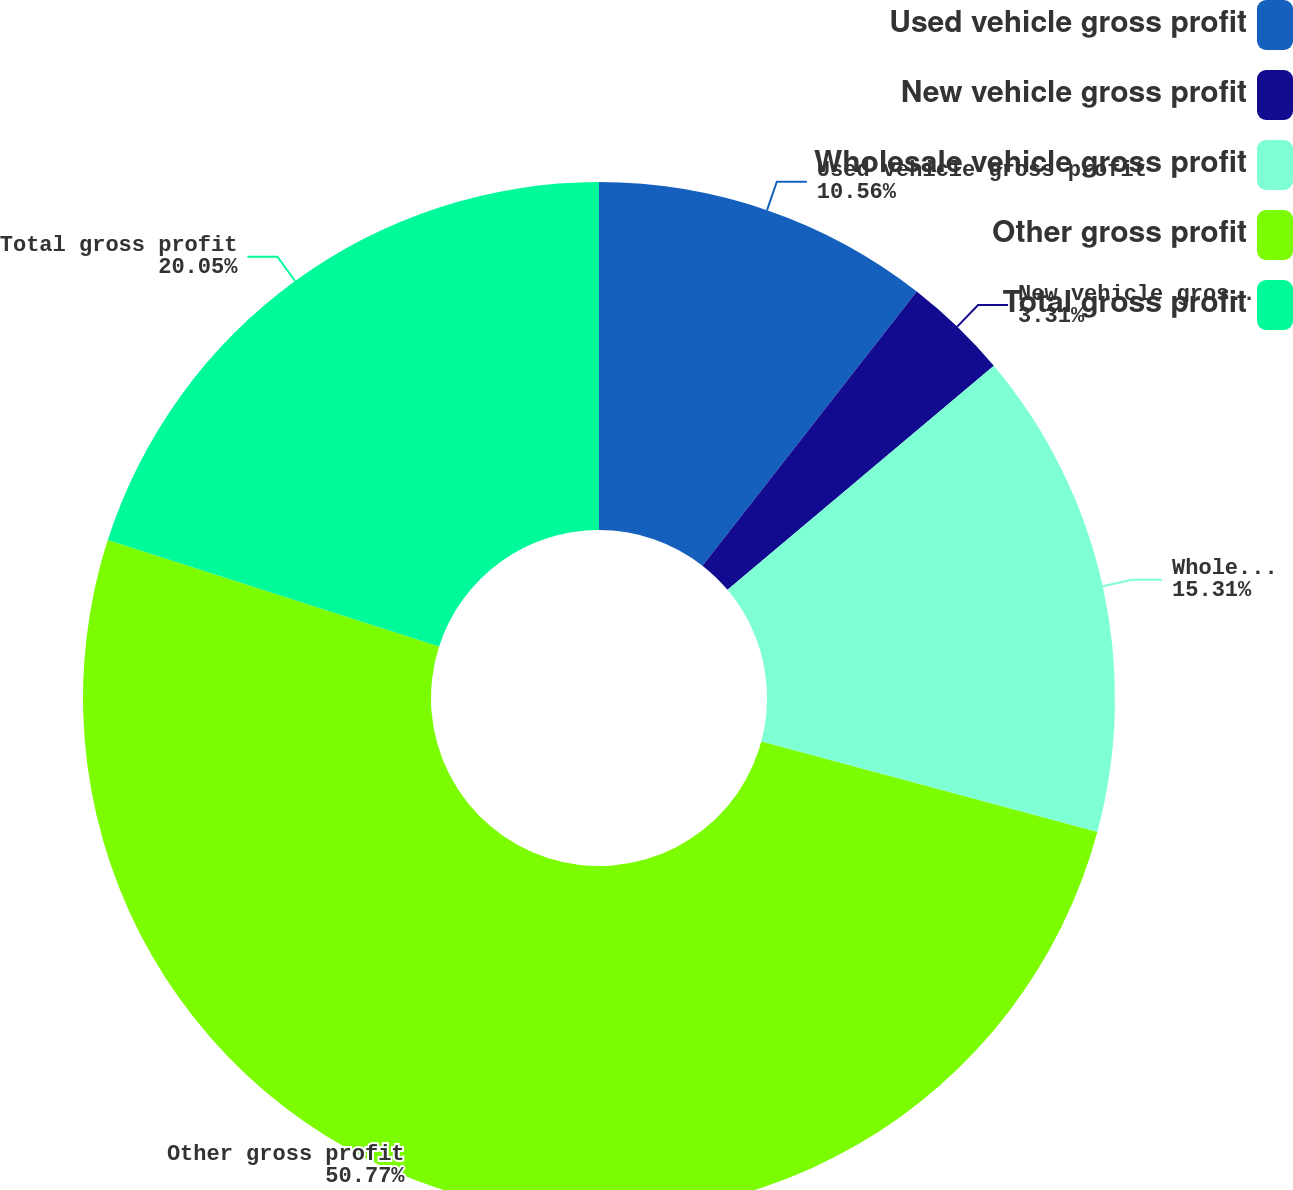Convert chart. <chart><loc_0><loc_0><loc_500><loc_500><pie_chart><fcel>Used vehicle gross profit<fcel>New vehicle gross profit<fcel>Wholesale vehicle gross profit<fcel>Other gross profit<fcel>Total gross profit<nl><fcel>10.56%<fcel>3.31%<fcel>15.31%<fcel>50.78%<fcel>20.05%<nl></chart> 